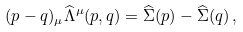Convert formula to latex. <formula><loc_0><loc_0><loc_500><loc_500>( p - q ) _ { \mu } \widehat { \Lambda } ^ { \mu } ( p , q ) = \widehat { \Sigma } ( p ) - \widehat { \Sigma } ( q ) \, ,</formula> 